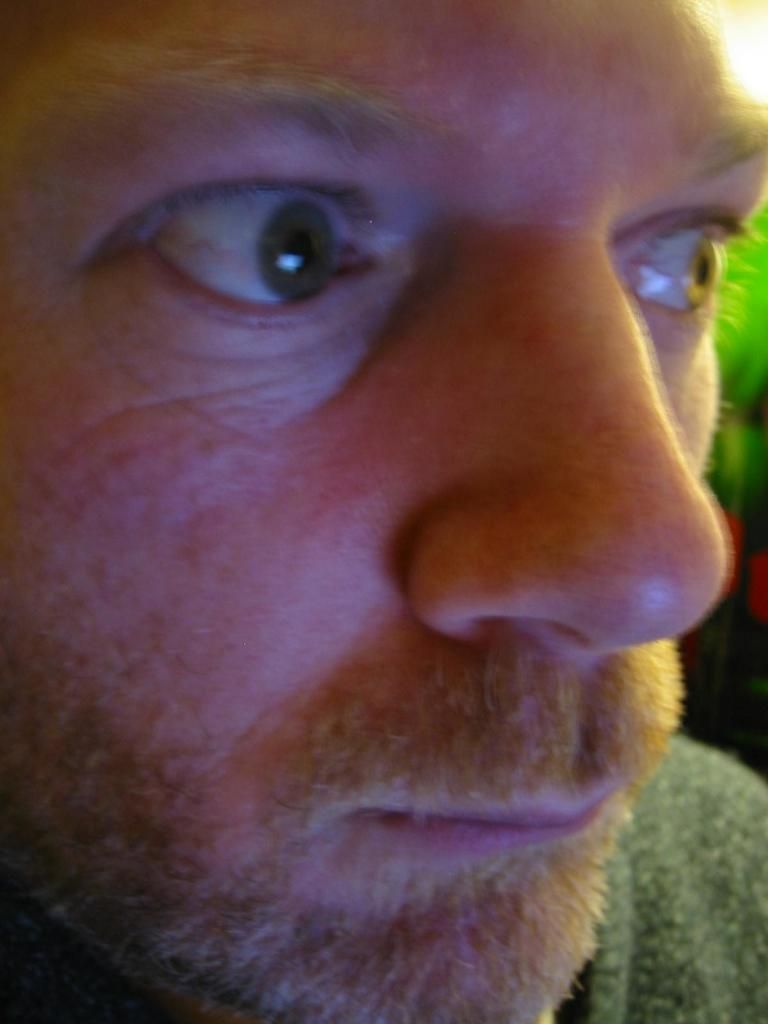What is the main subject of the image? The main subject of the image is a man's face. What type of tax is being discussed in the image? There is no discussion of tax in the image; it features a man's face. What type of fuel is being used in the image? There is no fuel or reference to fuel in the image; it features a man's face. 